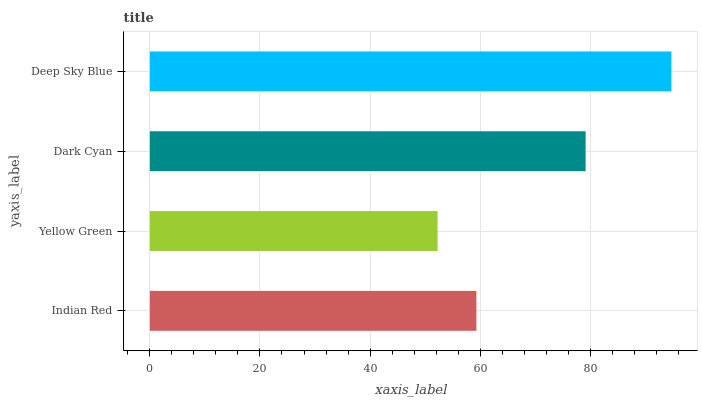Is Yellow Green the minimum?
Answer yes or no. Yes. Is Deep Sky Blue the maximum?
Answer yes or no. Yes. Is Dark Cyan the minimum?
Answer yes or no. No. Is Dark Cyan the maximum?
Answer yes or no. No. Is Dark Cyan greater than Yellow Green?
Answer yes or no. Yes. Is Yellow Green less than Dark Cyan?
Answer yes or no. Yes. Is Yellow Green greater than Dark Cyan?
Answer yes or no. No. Is Dark Cyan less than Yellow Green?
Answer yes or no. No. Is Dark Cyan the high median?
Answer yes or no. Yes. Is Indian Red the low median?
Answer yes or no. Yes. Is Yellow Green the high median?
Answer yes or no. No. Is Yellow Green the low median?
Answer yes or no. No. 